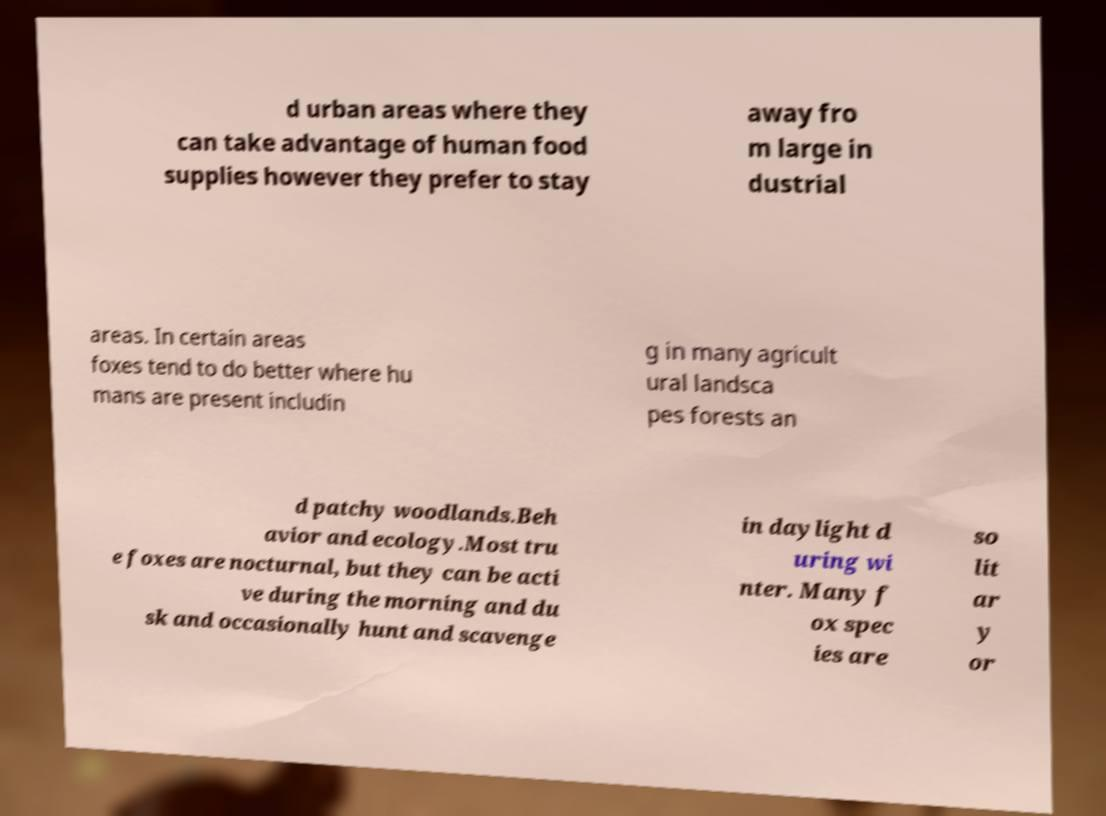I need the written content from this picture converted into text. Can you do that? d urban areas where they can take advantage of human food supplies however they prefer to stay away fro m large in dustrial areas. In certain areas foxes tend to do better where hu mans are present includin g in many agricult ural landsca pes forests an d patchy woodlands.Beh avior and ecology.Most tru e foxes are nocturnal, but they can be acti ve during the morning and du sk and occasionally hunt and scavenge in daylight d uring wi nter. Many f ox spec ies are so lit ar y or 